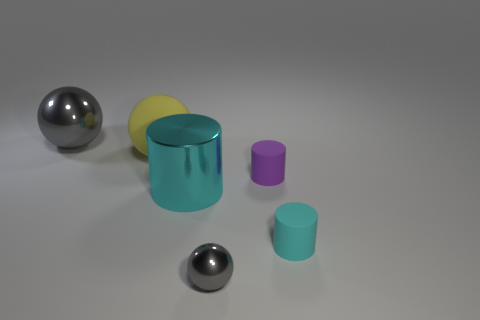There is a big thing that is the same color as the tiny sphere; what is it made of? metal 